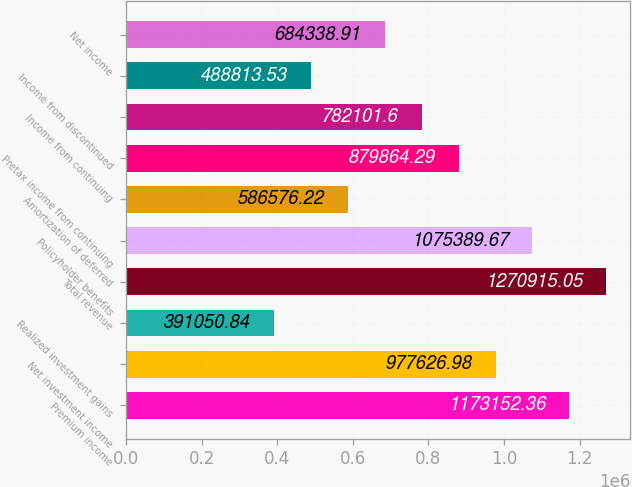Convert chart to OTSL. <chart><loc_0><loc_0><loc_500><loc_500><bar_chart><fcel>Premium income<fcel>Net investment income<fcel>Realized investment gains<fcel>Total revenue<fcel>Policyholder benefits<fcel>Amortization of deferred<fcel>Pretax income from continuing<fcel>Income from continuing<fcel>Income from discontinued<fcel>Net income<nl><fcel>1.17315e+06<fcel>977627<fcel>391051<fcel>1.27092e+06<fcel>1.07539e+06<fcel>586576<fcel>879864<fcel>782102<fcel>488814<fcel>684339<nl></chart> 